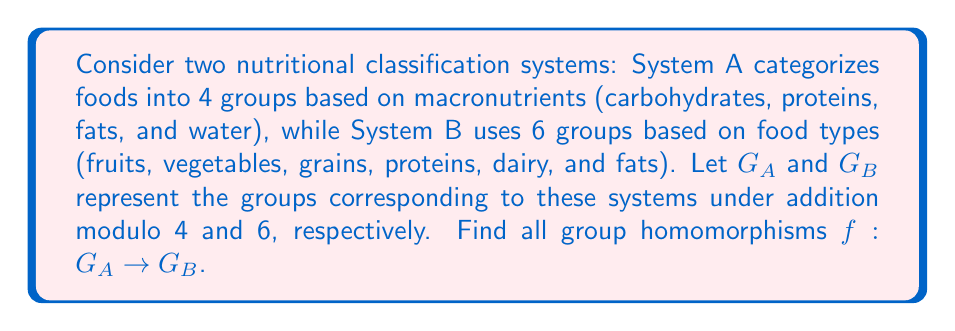Provide a solution to this math problem. To find all group homomorphisms $f: G_A \to G_B$, we need to consider the following steps:

1) First, we need to understand the structure of $G_A$ and $G_B$:
   $G_A \cong \mathbb{Z}_4$ (cyclic group of order 4)
   $G_B \cong \mathbb{Z}_6$ (cyclic group of order 6)

2) A homomorphism $f: G_A \to G_B$ must satisfy $f(a+b) = f(a) + f(b)$ for all $a,b \in G_A$.

3) Since $G_A$ is cyclic, it's sufficient to determine $f(1)$, as this will define the entire homomorphism.

4) Let $f(1) = k \in G_B$. Then $f(2) = f(1+1) = f(1) + f(1) = k + k = 2k$, and similarly $f(3) = 3k$.

5) We must have $f(4) = f(0) = 0$ in $G_B$, because homomorphisms map the identity to the identity.

6) This means $4k \equiv 0 \pmod{6}$ must hold.

7) Solving this congruence:
   $4k \equiv 0 \pmod{6}$
   $2k \equiv 0 \pmod{3}$
   $k \equiv 0 \pmod{3}$

8) The only value of $k$ in $\mathbb{Z}_6$ satisfying this is $k = 0$ or $k = 3$.

Therefore, there are two group homomorphisms from $G_A$ to $G_B$:

1) The trivial homomorphism: $f(x) = 0$ for all $x \in G_A$
2) The homomorphism defined by $f(1) = 3$, which gives $f(0) = 0$, $f(1) = 3$, $f(2) = 0$, $f(3) = 3$
Answer: There are two group homomorphisms from $G_A$ to $G_B$:
1) $f(x) = 0$ for all $x \in G_A$
2) $f(x) = 3x \bmod 6$ for $x \in G_A$ 